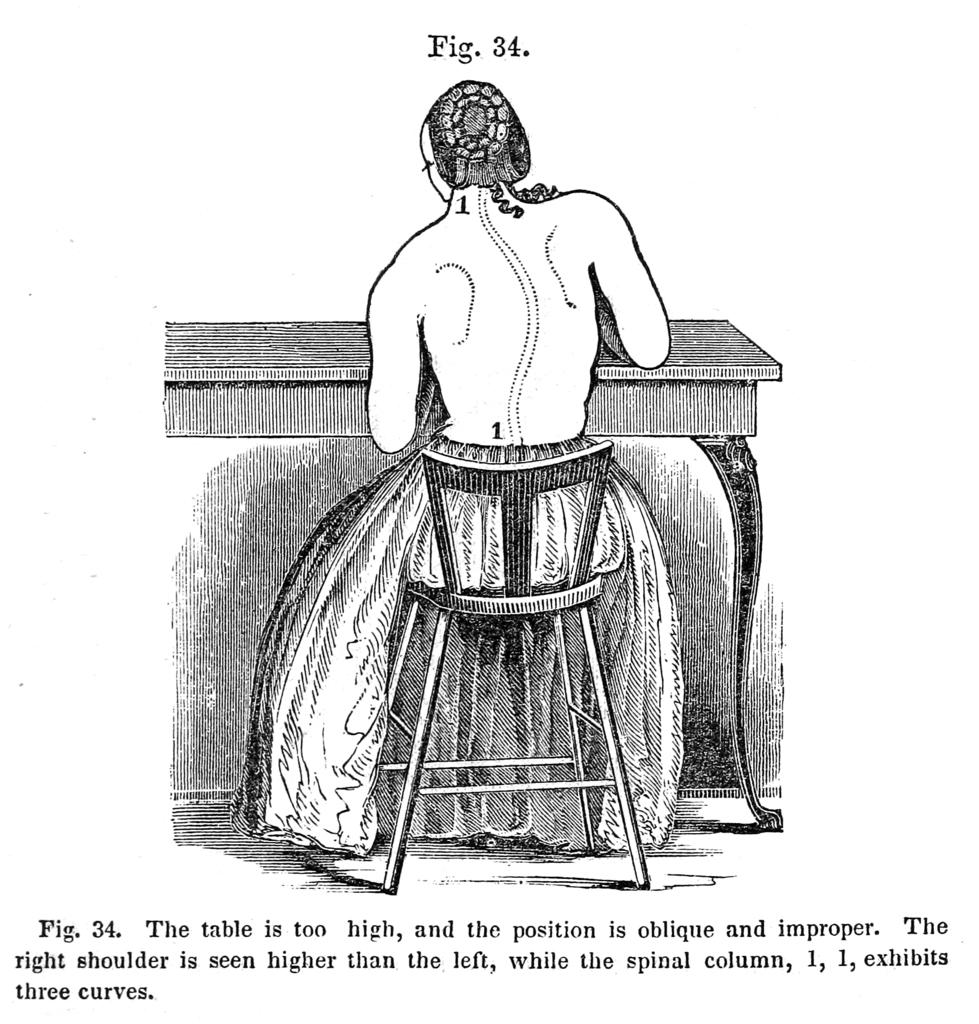What type of object is the image a part of? The image is a page of a book. What is the person in the image doing? The person is sitting at a table. What is the person sitting on? The person is sitting on a chair. What can be found at the bottom of the image? There is text at the bottom of the image. What color is the bead on the person's knee in the image? There is no bead or mention of a knee in the image; it only shows a person sitting at a table with text at the bottom. 